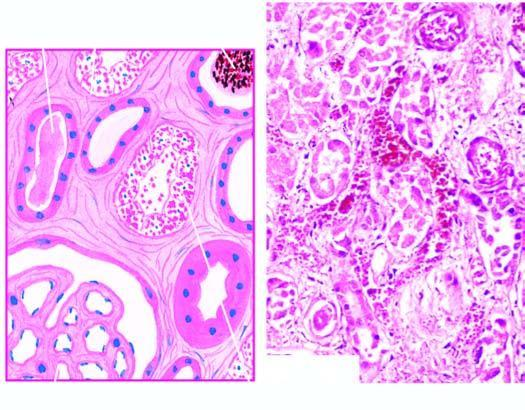what are lined by regenerating thin and flat epithelium?
Answer the question using a single word or phrase. Affected regions 